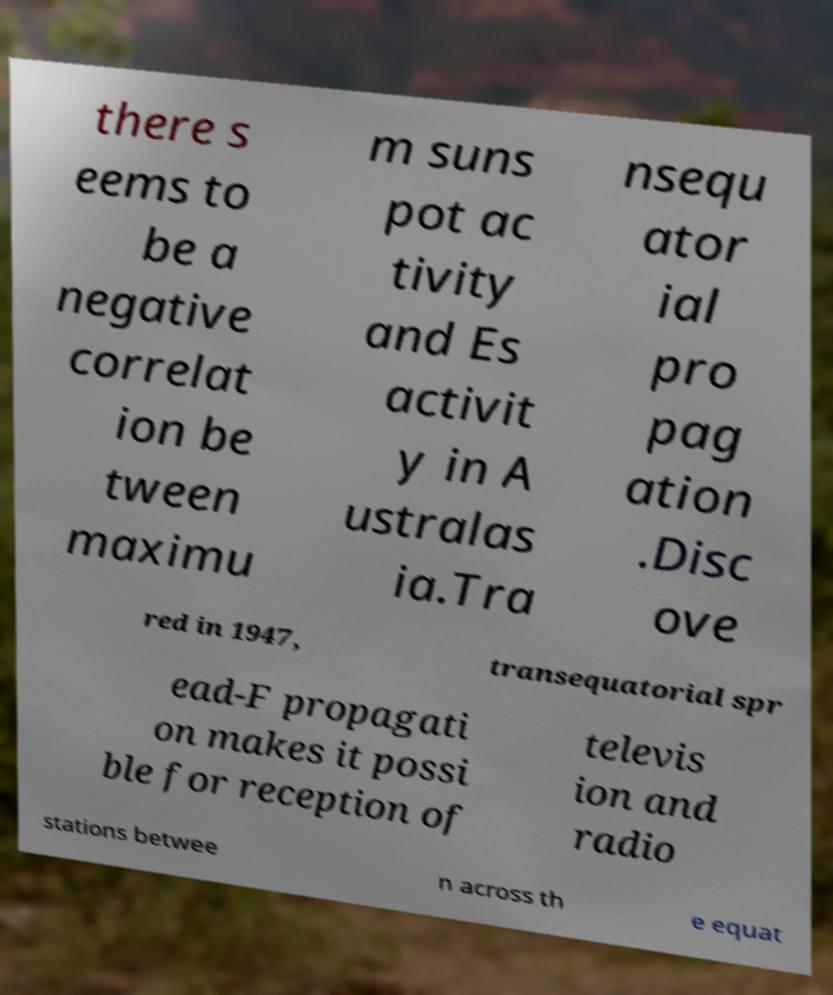Could you extract and type out the text from this image? there s eems to be a negative correlat ion be tween maximu m suns pot ac tivity and Es activit y in A ustralas ia.Tra nsequ ator ial pro pag ation .Disc ove red in 1947, transequatorial spr ead-F propagati on makes it possi ble for reception of televis ion and radio stations betwee n across th e equat 